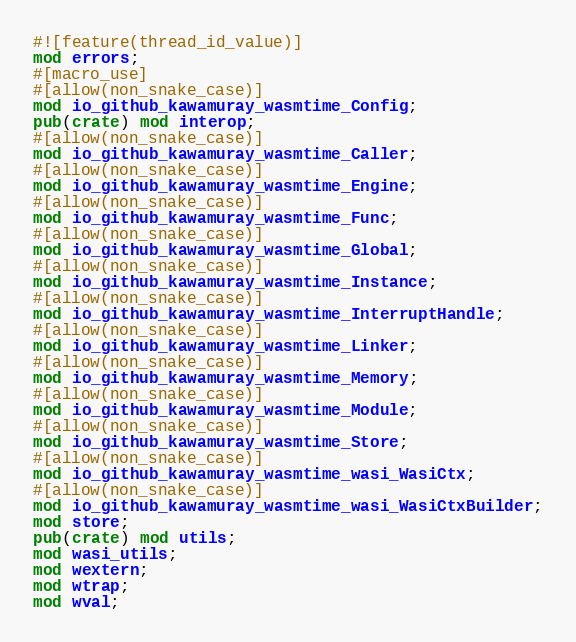<code> <loc_0><loc_0><loc_500><loc_500><_Rust_>#![feature(thread_id_value)]
mod errors;
#[macro_use]
#[allow(non_snake_case)]
mod io_github_kawamuray_wasmtime_Config;
pub(crate) mod interop;
#[allow(non_snake_case)]
mod io_github_kawamuray_wasmtime_Caller;
#[allow(non_snake_case)]
mod io_github_kawamuray_wasmtime_Engine;
#[allow(non_snake_case)]
mod io_github_kawamuray_wasmtime_Func;
#[allow(non_snake_case)]
mod io_github_kawamuray_wasmtime_Global;
#[allow(non_snake_case)]
mod io_github_kawamuray_wasmtime_Instance;
#[allow(non_snake_case)]
mod io_github_kawamuray_wasmtime_InterruptHandle;
#[allow(non_snake_case)]
mod io_github_kawamuray_wasmtime_Linker;
#[allow(non_snake_case)]
mod io_github_kawamuray_wasmtime_Memory;
#[allow(non_snake_case)]
mod io_github_kawamuray_wasmtime_Module;
#[allow(non_snake_case)]
mod io_github_kawamuray_wasmtime_Store;
#[allow(non_snake_case)]
mod io_github_kawamuray_wasmtime_wasi_WasiCtx;
#[allow(non_snake_case)]
mod io_github_kawamuray_wasmtime_wasi_WasiCtxBuilder;
mod store;
pub(crate) mod utils;
mod wasi_utils;
mod wextern;
mod wtrap;
mod wval;
</code> 